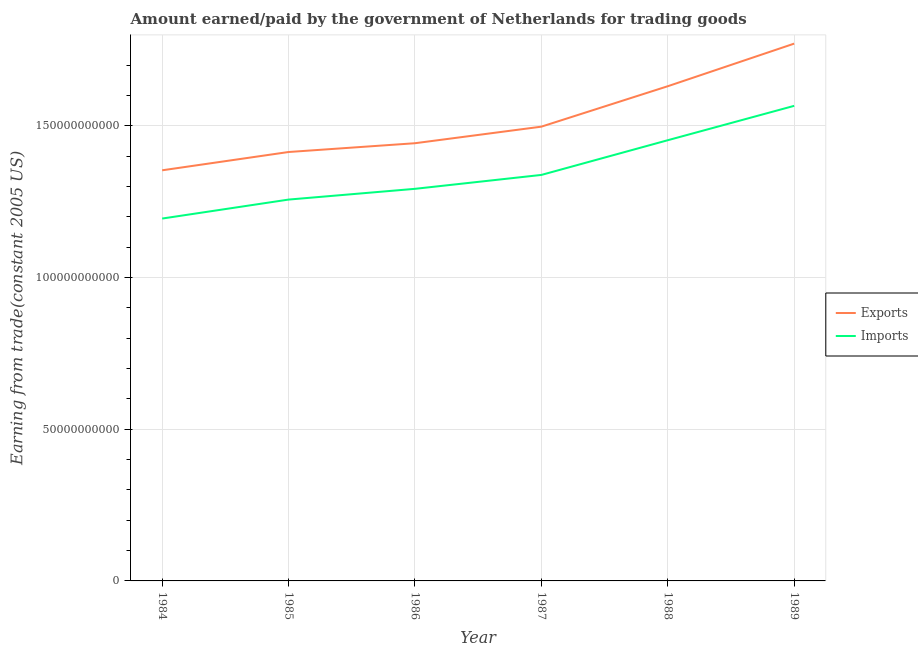How many different coloured lines are there?
Offer a terse response. 2. What is the amount earned from exports in 1986?
Offer a terse response. 1.44e+11. Across all years, what is the maximum amount paid for imports?
Provide a short and direct response. 1.57e+11. Across all years, what is the minimum amount paid for imports?
Keep it short and to the point. 1.19e+11. In which year was the amount paid for imports minimum?
Provide a succinct answer. 1984. What is the total amount paid for imports in the graph?
Make the answer very short. 8.10e+11. What is the difference between the amount paid for imports in 1986 and that in 1987?
Provide a short and direct response. -4.58e+09. What is the difference between the amount earned from exports in 1985 and the amount paid for imports in 1984?
Make the answer very short. 2.19e+1. What is the average amount earned from exports per year?
Keep it short and to the point. 1.52e+11. In the year 1987, what is the difference between the amount paid for imports and amount earned from exports?
Keep it short and to the point. -1.59e+1. What is the ratio of the amount paid for imports in 1985 to that in 1987?
Offer a very short reply. 0.94. Is the amount earned from exports in 1986 less than that in 1989?
Your answer should be very brief. Yes. Is the difference between the amount earned from exports in 1984 and 1988 greater than the difference between the amount paid for imports in 1984 and 1988?
Offer a terse response. No. What is the difference between the highest and the second highest amount paid for imports?
Keep it short and to the point. 1.13e+1. What is the difference between the highest and the lowest amount earned from exports?
Offer a terse response. 4.17e+1. How many years are there in the graph?
Offer a terse response. 6. How many legend labels are there?
Ensure brevity in your answer.  2. What is the title of the graph?
Offer a very short reply. Amount earned/paid by the government of Netherlands for trading goods. Does "Formally registered" appear as one of the legend labels in the graph?
Ensure brevity in your answer.  No. What is the label or title of the Y-axis?
Provide a succinct answer. Earning from trade(constant 2005 US). What is the Earning from trade(constant 2005 US) in Exports in 1984?
Provide a short and direct response. 1.35e+11. What is the Earning from trade(constant 2005 US) in Imports in 1984?
Make the answer very short. 1.19e+11. What is the Earning from trade(constant 2005 US) of Exports in 1985?
Your answer should be very brief. 1.41e+11. What is the Earning from trade(constant 2005 US) in Imports in 1985?
Keep it short and to the point. 1.26e+11. What is the Earning from trade(constant 2005 US) of Exports in 1986?
Your answer should be compact. 1.44e+11. What is the Earning from trade(constant 2005 US) of Imports in 1986?
Provide a short and direct response. 1.29e+11. What is the Earning from trade(constant 2005 US) in Exports in 1987?
Make the answer very short. 1.50e+11. What is the Earning from trade(constant 2005 US) in Imports in 1987?
Your answer should be compact. 1.34e+11. What is the Earning from trade(constant 2005 US) of Exports in 1988?
Make the answer very short. 1.63e+11. What is the Earning from trade(constant 2005 US) in Imports in 1988?
Provide a short and direct response. 1.45e+11. What is the Earning from trade(constant 2005 US) of Exports in 1989?
Offer a terse response. 1.77e+11. What is the Earning from trade(constant 2005 US) of Imports in 1989?
Provide a succinct answer. 1.57e+11. Across all years, what is the maximum Earning from trade(constant 2005 US) in Exports?
Give a very brief answer. 1.77e+11. Across all years, what is the maximum Earning from trade(constant 2005 US) in Imports?
Ensure brevity in your answer.  1.57e+11. Across all years, what is the minimum Earning from trade(constant 2005 US) in Exports?
Provide a short and direct response. 1.35e+11. Across all years, what is the minimum Earning from trade(constant 2005 US) in Imports?
Your response must be concise. 1.19e+11. What is the total Earning from trade(constant 2005 US) in Exports in the graph?
Offer a terse response. 9.11e+11. What is the total Earning from trade(constant 2005 US) of Imports in the graph?
Offer a terse response. 8.10e+11. What is the difference between the Earning from trade(constant 2005 US) in Exports in 1984 and that in 1985?
Make the answer very short. -6.03e+09. What is the difference between the Earning from trade(constant 2005 US) in Imports in 1984 and that in 1985?
Your answer should be very brief. -6.25e+09. What is the difference between the Earning from trade(constant 2005 US) in Exports in 1984 and that in 1986?
Your answer should be compact. -8.92e+09. What is the difference between the Earning from trade(constant 2005 US) in Imports in 1984 and that in 1986?
Your answer should be compact. -9.80e+09. What is the difference between the Earning from trade(constant 2005 US) in Exports in 1984 and that in 1987?
Provide a succinct answer. -1.44e+1. What is the difference between the Earning from trade(constant 2005 US) of Imports in 1984 and that in 1987?
Your answer should be very brief. -1.44e+1. What is the difference between the Earning from trade(constant 2005 US) of Exports in 1984 and that in 1988?
Make the answer very short. -2.77e+1. What is the difference between the Earning from trade(constant 2005 US) of Imports in 1984 and that in 1988?
Provide a succinct answer. -2.58e+1. What is the difference between the Earning from trade(constant 2005 US) of Exports in 1984 and that in 1989?
Your answer should be compact. -4.17e+1. What is the difference between the Earning from trade(constant 2005 US) in Imports in 1984 and that in 1989?
Your answer should be compact. -3.71e+1. What is the difference between the Earning from trade(constant 2005 US) in Exports in 1985 and that in 1986?
Offer a terse response. -2.89e+09. What is the difference between the Earning from trade(constant 2005 US) in Imports in 1985 and that in 1986?
Give a very brief answer. -3.54e+09. What is the difference between the Earning from trade(constant 2005 US) of Exports in 1985 and that in 1987?
Offer a very short reply. -8.35e+09. What is the difference between the Earning from trade(constant 2005 US) in Imports in 1985 and that in 1987?
Keep it short and to the point. -8.12e+09. What is the difference between the Earning from trade(constant 2005 US) of Exports in 1985 and that in 1988?
Make the answer very short. -2.17e+1. What is the difference between the Earning from trade(constant 2005 US) in Imports in 1985 and that in 1988?
Offer a terse response. -1.96e+1. What is the difference between the Earning from trade(constant 2005 US) in Exports in 1985 and that in 1989?
Offer a very short reply. -3.57e+1. What is the difference between the Earning from trade(constant 2005 US) of Imports in 1985 and that in 1989?
Provide a succinct answer. -3.09e+1. What is the difference between the Earning from trade(constant 2005 US) in Exports in 1986 and that in 1987?
Keep it short and to the point. -5.46e+09. What is the difference between the Earning from trade(constant 2005 US) of Imports in 1986 and that in 1987?
Give a very brief answer. -4.58e+09. What is the difference between the Earning from trade(constant 2005 US) of Exports in 1986 and that in 1988?
Your response must be concise. -1.88e+1. What is the difference between the Earning from trade(constant 2005 US) of Imports in 1986 and that in 1988?
Your response must be concise. -1.60e+1. What is the difference between the Earning from trade(constant 2005 US) of Exports in 1986 and that in 1989?
Your response must be concise. -3.28e+1. What is the difference between the Earning from trade(constant 2005 US) in Imports in 1986 and that in 1989?
Your response must be concise. -2.73e+1. What is the difference between the Earning from trade(constant 2005 US) of Exports in 1987 and that in 1988?
Keep it short and to the point. -1.33e+1. What is the difference between the Earning from trade(constant 2005 US) in Imports in 1987 and that in 1988?
Provide a succinct answer. -1.14e+1. What is the difference between the Earning from trade(constant 2005 US) in Exports in 1987 and that in 1989?
Make the answer very short. -2.74e+1. What is the difference between the Earning from trade(constant 2005 US) of Imports in 1987 and that in 1989?
Give a very brief answer. -2.28e+1. What is the difference between the Earning from trade(constant 2005 US) of Exports in 1988 and that in 1989?
Your response must be concise. -1.40e+1. What is the difference between the Earning from trade(constant 2005 US) in Imports in 1988 and that in 1989?
Offer a terse response. -1.13e+1. What is the difference between the Earning from trade(constant 2005 US) of Exports in 1984 and the Earning from trade(constant 2005 US) of Imports in 1985?
Provide a short and direct response. 9.65e+09. What is the difference between the Earning from trade(constant 2005 US) in Exports in 1984 and the Earning from trade(constant 2005 US) in Imports in 1986?
Offer a very short reply. 6.10e+09. What is the difference between the Earning from trade(constant 2005 US) of Exports in 1984 and the Earning from trade(constant 2005 US) of Imports in 1987?
Offer a terse response. 1.52e+09. What is the difference between the Earning from trade(constant 2005 US) of Exports in 1984 and the Earning from trade(constant 2005 US) of Imports in 1988?
Provide a succinct answer. -9.92e+09. What is the difference between the Earning from trade(constant 2005 US) in Exports in 1984 and the Earning from trade(constant 2005 US) in Imports in 1989?
Provide a succinct answer. -2.12e+1. What is the difference between the Earning from trade(constant 2005 US) in Exports in 1985 and the Earning from trade(constant 2005 US) in Imports in 1986?
Your response must be concise. 1.21e+1. What is the difference between the Earning from trade(constant 2005 US) of Exports in 1985 and the Earning from trade(constant 2005 US) of Imports in 1987?
Provide a succinct answer. 7.55e+09. What is the difference between the Earning from trade(constant 2005 US) in Exports in 1985 and the Earning from trade(constant 2005 US) in Imports in 1988?
Ensure brevity in your answer.  -3.88e+09. What is the difference between the Earning from trade(constant 2005 US) of Exports in 1985 and the Earning from trade(constant 2005 US) of Imports in 1989?
Offer a terse response. -1.52e+1. What is the difference between the Earning from trade(constant 2005 US) in Exports in 1986 and the Earning from trade(constant 2005 US) in Imports in 1987?
Make the answer very short. 1.04e+1. What is the difference between the Earning from trade(constant 2005 US) of Exports in 1986 and the Earning from trade(constant 2005 US) of Imports in 1988?
Your answer should be compact. -9.91e+08. What is the difference between the Earning from trade(constant 2005 US) of Exports in 1986 and the Earning from trade(constant 2005 US) of Imports in 1989?
Provide a short and direct response. -1.23e+1. What is the difference between the Earning from trade(constant 2005 US) in Exports in 1987 and the Earning from trade(constant 2005 US) in Imports in 1988?
Provide a short and direct response. 4.47e+09. What is the difference between the Earning from trade(constant 2005 US) in Exports in 1987 and the Earning from trade(constant 2005 US) in Imports in 1989?
Give a very brief answer. -6.86e+09. What is the difference between the Earning from trade(constant 2005 US) in Exports in 1988 and the Earning from trade(constant 2005 US) in Imports in 1989?
Your answer should be compact. 6.46e+09. What is the average Earning from trade(constant 2005 US) in Exports per year?
Ensure brevity in your answer.  1.52e+11. What is the average Earning from trade(constant 2005 US) of Imports per year?
Make the answer very short. 1.35e+11. In the year 1984, what is the difference between the Earning from trade(constant 2005 US) of Exports and Earning from trade(constant 2005 US) of Imports?
Offer a very short reply. 1.59e+1. In the year 1985, what is the difference between the Earning from trade(constant 2005 US) of Exports and Earning from trade(constant 2005 US) of Imports?
Offer a very short reply. 1.57e+1. In the year 1986, what is the difference between the Earning from trade(constant 2005 US) of Exports and Earning from trade(constant 2005 US) of Imports?
Your answer should be very brief. 1.50e+1. In the year 1987, what is the difference between the Earning from trade(constant 2005 US) of Exports and Earning from trade(constant 2005 US) of Imports?
Ensure brevity in your answer.  1.59e+1. In the year 1988, what is the difference between the Earning from trade(constant 2005 US) in Exports and Earning from trade(constant 2005 US) in Imports?
Your answer should be very brief. 1.78e+1. In the year 1989, what is the difference between the Earning from trade(constant 2005 US) in Exports and Earning from trade(constant 2005 US) in Imports?
Your answer should be very brief. 2.05e+1. What is the ratio of the Earning from trade(constant 2005 US) in Exports in 1984 to that in 1985?
Make the answer very short. 0.96. What is the ratio of the Earning from trade(constant 2005 US) of Imports in 1984 to that in 1985?
Ensure brevity in your answer.  0.95. What is the ratio of the Earning from trade(constant 2005 US) of Exports in 1984 to that in 1986?
Offer a terse response. 0.94. What is the ratio of the Earning from trade(constant 2005 US) of Imports in 1984 to that in 1986?
Your response must be concise. 0.92. What is the ratio of the Earning from trade(constant 2005 US) of Exports in 1984 to that in 1987?
Give a very brief answer. 0.9. What is the ratio of the Earning from trade(constant 2005 US) of Imports in 1984 to that in 1987?
Offer a terse response. 0.89. What is the ratio of the Earning from trade(constant 2005 US) in Exports in 1984 to that in 1988?
Your answer should be very brief. 0.83. What is the ratio of the Earning from trade(constant 2005 US) in Imports in 1984 to that in 1988?
Offer a very short reply. 0.82. What is the ratio of the Earning from trade(constant 2005 US) in Exports in 1984 to that in 1989?
Keep it short and to the point. 0.76. What is the ratio of the Earning from trade(constant 2005 US) of Imports in 1984 to that in 1989?
Provide a succinct answer. 0.76. What is the ratio of the Earning from trade(constant 2005 US) in Exports in 1985 to that in 1986?
Make the answer very short. 0.98. What is the ratio of the Earning from trade(constant 2005 US) of Imports in 1985 to that in 1986?
Your response must be concise. 0.97. What is the ratio of the Earning from trade(constant 2005 US) of Exports in 1985 to that in 1987?
Your response must be concise. 0.94. What is the ratio of the Earning from trade(constant 2005 US) in Imports in 1985 to that in 1987?
Offer a very short reply. 0.94. What is the ratio of the Earning from trade(constant 2005 US) of Exports in 1985 to that in 1988?
Your answer should be compact. 0.87. What is the ratio of the Earning from trade(constant 2005 US) of Imports in 1985 to that in 1988?
Make the answer very short. 0.87. What is the ratio of the Earning from trade(constant 2005 US) in Exports in 1985 to that in 1989?
Ensure brevity in your answer.  0.8. What is the ratio of the Earning from trade(constant 2005 US) of Imports in 1985 to that in 1989?
Your answer should be compact. 0.8. What is the ratio of the Earning from trade(constant 2005 US) of Exports in 1986 to that in 1987?
Your answer should be very brief. 0.96. What is the ratio of the Earning from trade(constant 2005 US) of Imports in 1986 to that in 1987?
Your answer should be very brief. 0.97. What is the ratio of the Earning from trade(constant 2005 US) of Exports in 1986 to that in 1988?
Ensure brevity in your answer.  0.88. What is the ratio of the Earning from trade(constant 2005 US) of Imports in 1986 to that in 1988?
Offer a terse response. 0.89. What is the ratio of the Earning from trade(constant 2005 US) of Exports in 1986 to that in 1989?
Your answer should be compact. 0.81. What is the ratio of the Earning from trade(constant 2005 US) of Imports in 1986 to that in 1989?
Make the answer very short. 0.83. What is the ratio of the Earning from trade(constant 2005 US) in Exports in 1987 to that in 1988?
Offer a terse response. 0.92. What is the ratio of the Earning from trade(constant 2005 US) in Imports in 1987 to that in 1988?
Offer a very short reply. 0.92. What is the ratio of the Earning from trade(constant 2005 US) of Exports in 1987 to that in 1989?
Your response must be concise. 0.85. What is the ratio of the Earning from trade(constant 2005 US) in Imports in 1987 to that in 1989?
Give a very brief answer. 0.85. What is the ratio of the Earning from trade(constant 2005 US) of Exports in 1988 to that in 1989?
Keep it short and to the point. 0.92. What is the ratio of the Earning from trade(constant 2005 US) in Imports in 1988 to that in 1989?
Provide a succinct answer. 0.93. What is the difference between the highest and the second highest Earning from trade(constant 2005 US) in Exports?
Provide a short and direct response. 1.40e+1. What is the difference between the highest and the second highest Earning from trade(constant 2005 US) in Imports?
Your response must be concise. 1.13e+1. What is the difference between the highest and the lowest Earning from trade(constant 2005 US) of Exports?
Your answer should be compact. 4.17e+1. What is the difference between the highest and the lowest Earning from trade(constant 2005 US) of Imports?
Keep it short and to the point. 3.71e+1. 